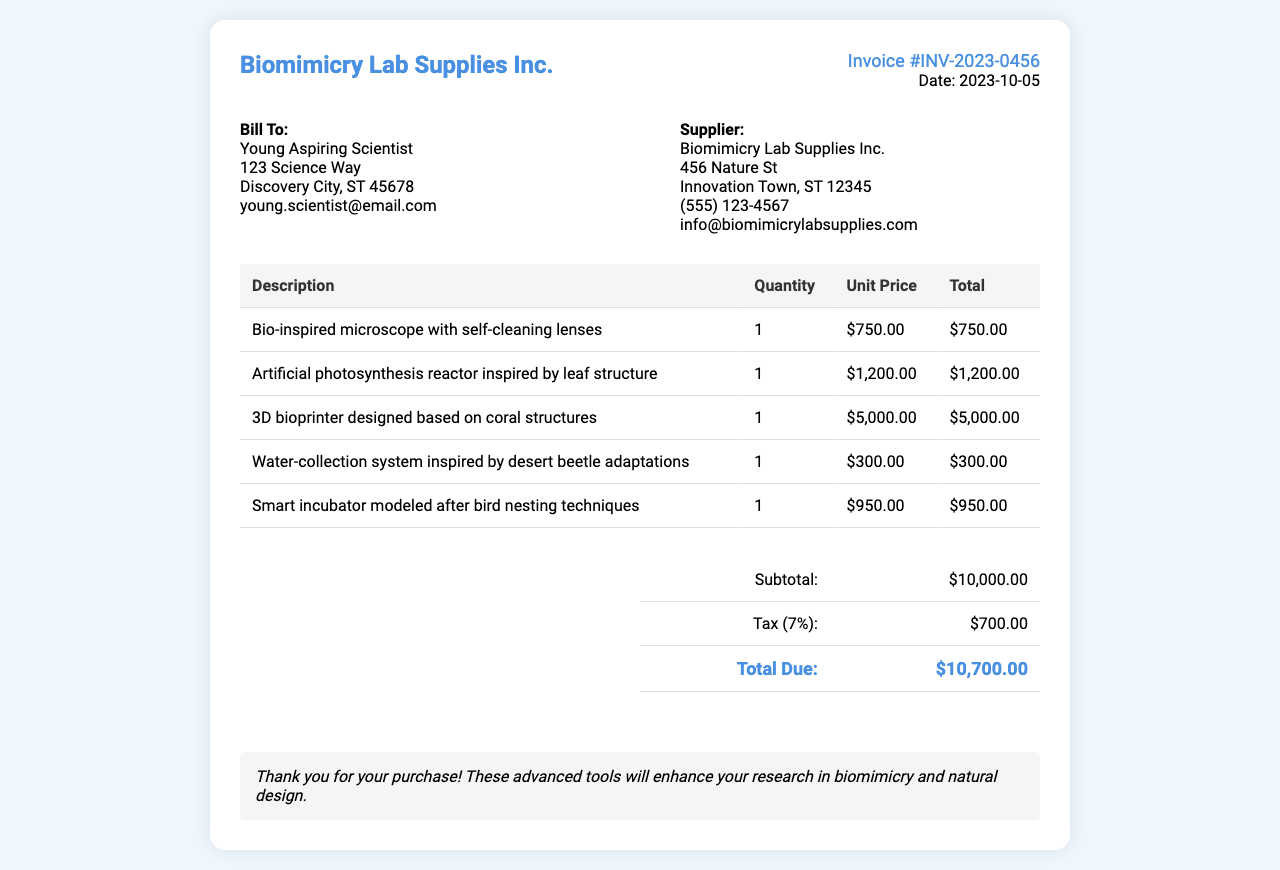What is the invoice number? The invoice number is provided in the invoice details section of the document.
Answer: INV-2023-0456 What is the date of the invoice? The date of the invoice is specified alongside the invoice number in the document.
Answer: 2023-10-05 Who is billed in this invoice? The recipient's name is mentioned in the bill to section of the document.
Answer: Young Aspiring Scientist What is the total due amount? The total due amount is calculated from the subtotal and tax values provided in the totals section.
Answer: $10,700.00 How many types of items are listed in the invoice? The number of different items can be counted from the list in the invoice table.
Answer: 5 What is the unit price of the 3D bioprinter? The unit price can be found in the itemized list provided in the invoice table.
Answer: $5,000.00 What inspired the design of the artificial photosynthesis reactor? The inspiration behind the design is mentioned in the description of the item in the invoice.
Answer: Leaf structure What is the tax rate used in the invoice? The tax rate is provided in the totals section and is calculated based on the subtotal.
Answer: 7% What is the subtotal amount before tax? The subtotal amount is shown clearly in the totals section of the invoice.
Answer: $10,000.00 What item is modeled after bird nesting techniques? The specific item inspired by bird nesting techniques is listed in the invoice.
Answer: Smart incubator 